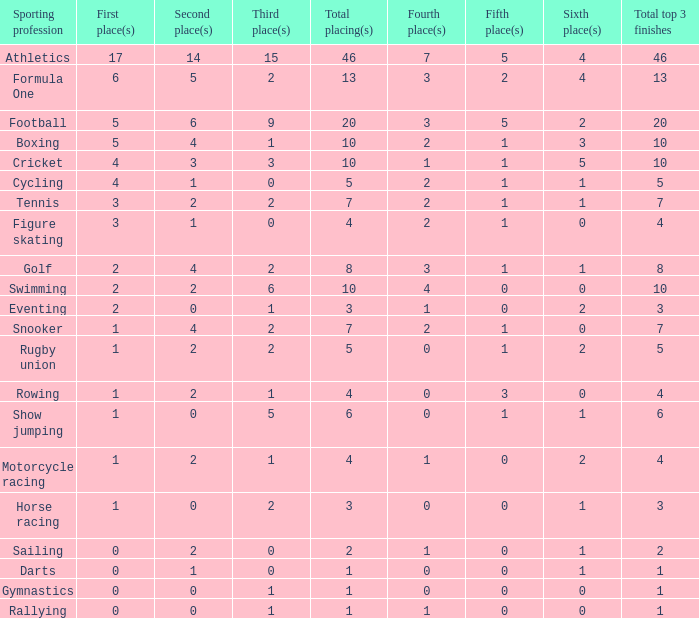What is the total number of 3rd place entries that have exactly 8 total placings? 1.0. 